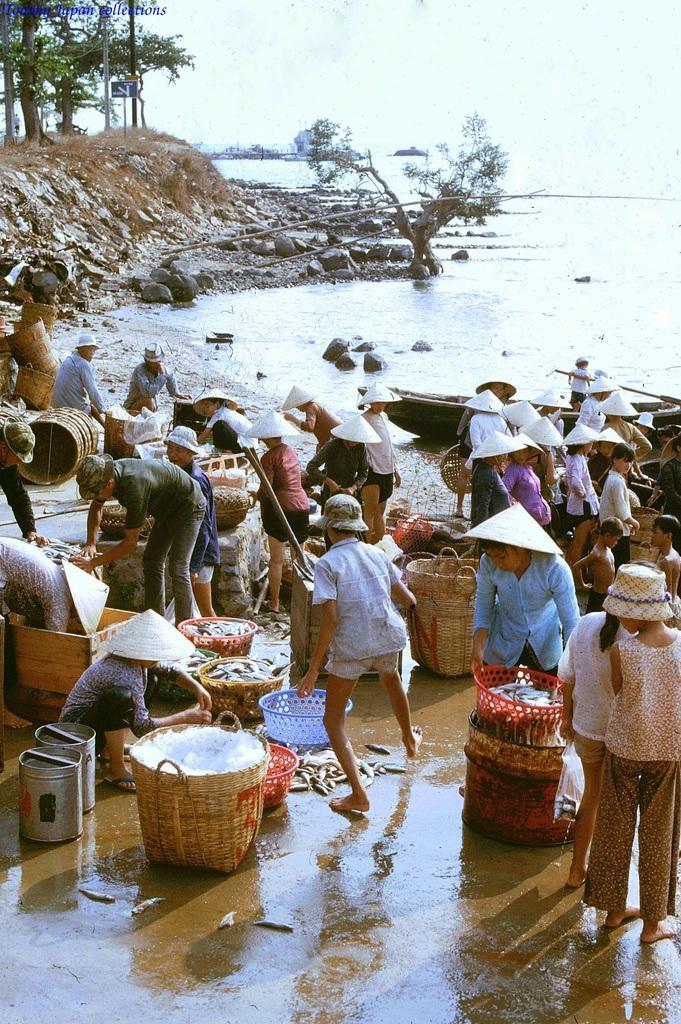How would you summarize this image in a sentence or two? In this picture we can see some people are standing in the front, some of them wore caps, there are some baskets and a box present at the bottom, on the right side we can see water and a boat, in the background there are some trees, stones and a board, there is the sky at the top of the picture, we can see some text at the left top of the picture. 